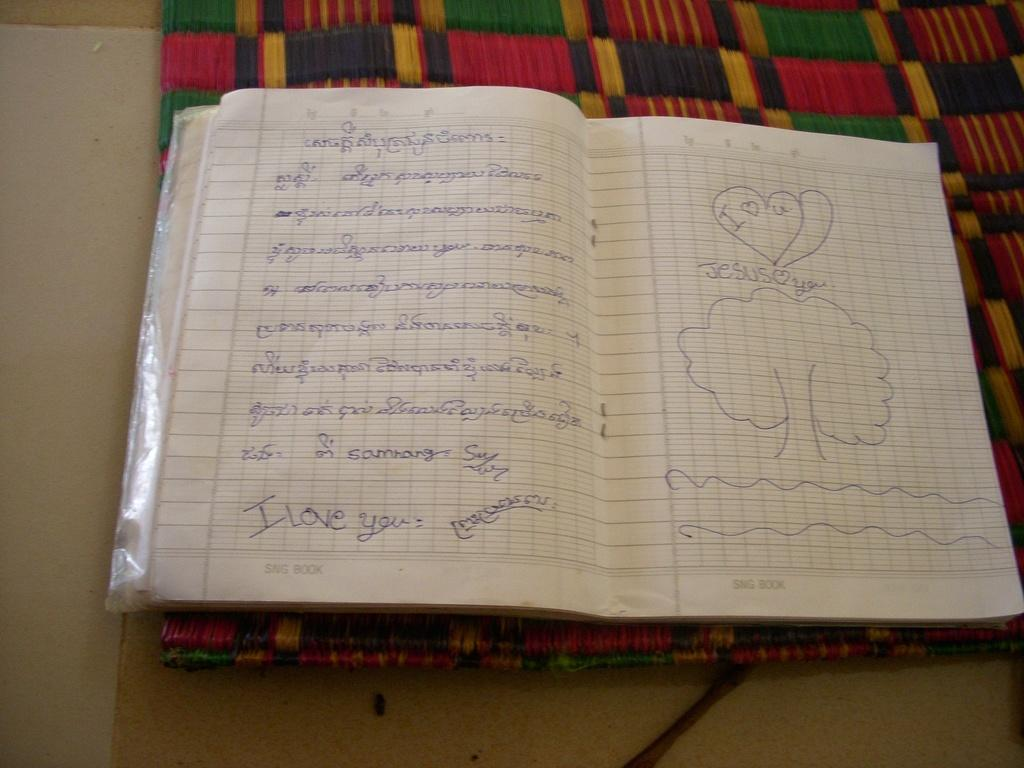<image>
Present a compact description of the photo's key features. A notebook has the line I love you written at the bottom of the page. 